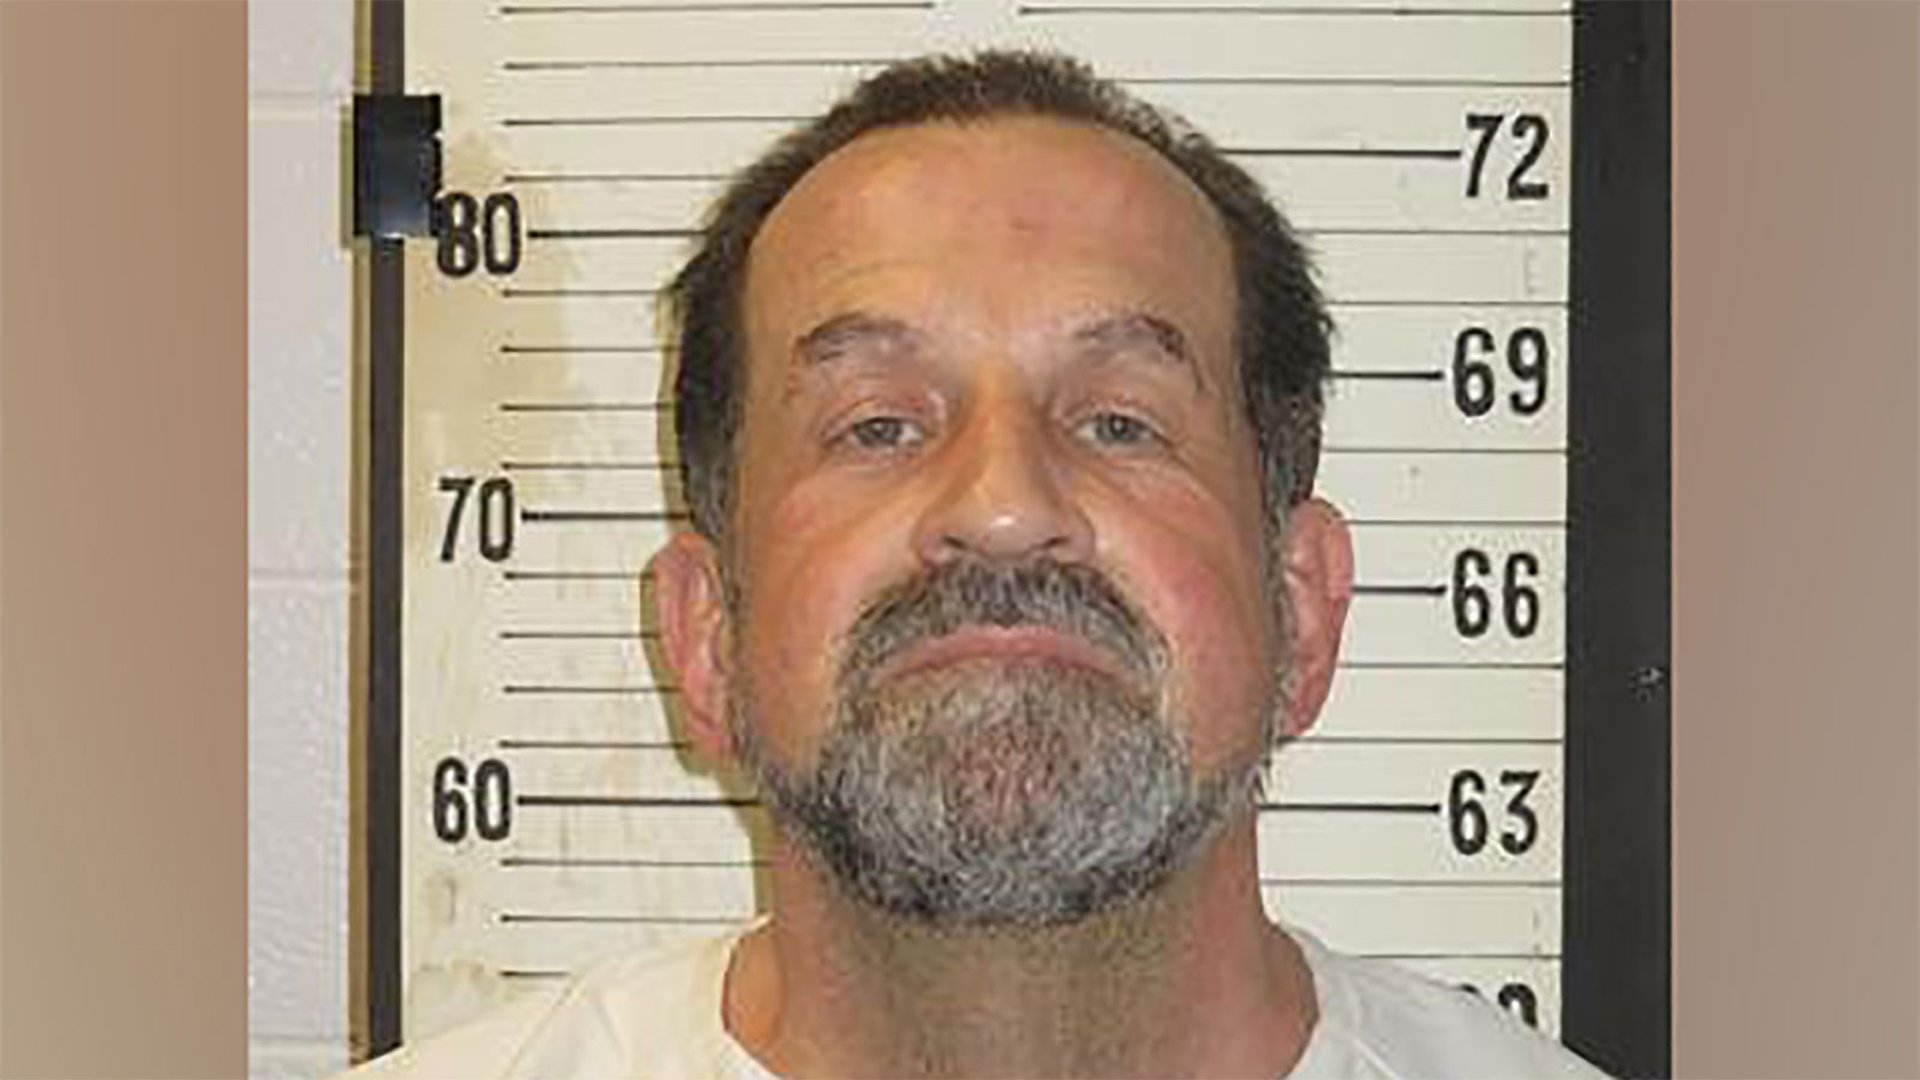Considering the man's expression and setting, what kind of conversation might he be having right now? The man's expression appears serious and slightly defiant, suggesting he might be involved in a tense conversation. Perhaps he is being questioned by authorities about a recent incident, or he is negotiating terms in a high-stakes legal matter. His demeanor indicates that he is likely asserting his perspective firmly, despite the formal and intimidating setting. 